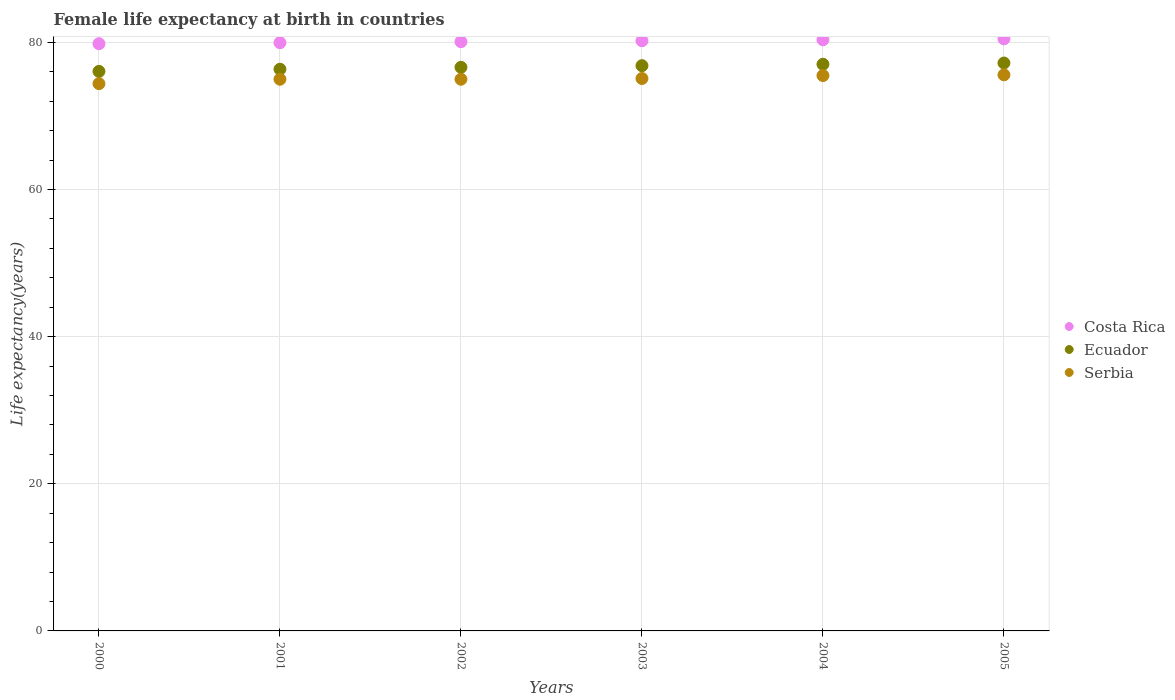How many different coloured dotlines are there?
Make the answer very short. 3. Is the number of dotlines equal to the number of legend labels?
Keep it short and to the point. Yes. What is the female life expectancy at birth in Ecuador in 2005?
Ensure brevity in your answer.  77.2. Across all years, what is the maximum female life expectancy at birth in Ecuador?
Make the answer very short. 77.2. Across all years, what is the minimum female life expectancy at birth in Costa Rica?
Provide a succinct answer. 79.83. In which year was the female life expectancy at birth in Costa Rica minimum?
Provide a short and direct response. 2000. What is the total female life expectancy at birth in Ecuador in the graph?
Keep it short and to the point. 460.13. What is the difference between the female life expectancy at birth in Ecuador in 2000 and that in 2005?
Make the answer very short. -1.14. What is the difference between the female life expectancy at birth in Ecuador in 2002 and the female life expectancy at birth in Costa Rica in 2005?
Your response must be concise. -3.87. What is the average female life expectancy at birth in Serbia per year?
Your response must be concise. 75.1. In the year 2001, what is the difference between the female life expectancy at birth in Serbia and female life expectancy at birth in Ecuador?
Offer a terse response. -1.36. What is the ratio of the female life expectancy at birth in Ecuador in 2001 to that in 2003?
Ensure brevity in your answer.  0.99. Is the female life expectancy at birth in Ecuador in 2001 less than that in 2005?
Provide a short and direct response. Yes. What is the difference between the highest and the second highest female life expectancy at birth in Ecuador?
Your response must be concise. 0.17. What is the difference between the highest and the lowest female life expectancy at birth in Ecuador?
Ensure brevity in your answer.  1.14. In how many years, is the female life expectancy at birth in Ecuador greater than the average female life expectancy at birth in Ecuador taken over all years?
Provide a succinct answer. 3. Is it the case that in every year, the sum of the female life expectancy at birth in Serbia and female life expectancy at birth in Ecuador  is greater than the female life expectancy at birth in Costa Rica?
Make the answer very short. Yes. Does the female life expectancy at birth in Ecuador monotonically increase over the years?
Provide a short and direct response. Yes. How many dotlines are there?
Provide a succinct answer. 3. How many years are there in the graph?
Give a very brief answer. 6. Are the values on the major ticks of Y-axis written in scientific E-notation?
Provide a short and direct response. No. Where does the legend appear in the graph?
Keep it short and to the point. Center right. What is the title of the graph?
Offer a very short reply. Female life expectancy at birth in countries. What is the label or title of the X-axis?
Keep it short and to the point. Years. What is the label or title of the Y-axis?
Your response must be concise. Life expectancy(years). What is the Life expectancy(years) of Costa Rica in 2000?
Your answer should be compact. 79.83. What is the Life expectancy(years) of Ecuador in 2000?
Give a very brief answer. 76.07. What is the Life expectancy(years) in Serbia in 2000?
Give a very brief answer. 74.4. What is the Life expectancy(years) of Costa Rica in 2001?
Provide a short and direct response. 79.97. What is the Life expectancy(years) of Ecuador in 2001?
Provide a short and direct response. 76.36. What is the Life expectancy(years) of Costa Rica in 2002?
Ensure brevity in your answer.  80.11. What is the Life expectancy(years) in Ecuador in 2002?
Give a very brief answer. 76.62. What is the Life expectancy(years) in Costa Rica in 2003?
Give a very brief answer. 80.24. What is the Life expectancy(years) in Ecuador in 2003?
Provide a short and direct response. 76.84. What is the Life expectancy(years) of Serbia in 2003?
Give a very brief answer. 75.1. What is the Life expectancy(years) in Costa Rica in 2004?
Give a very brief answer. 80.36. What is the Life expectancy(years) of Ecuador in 2004?
Provide a succinct answer. 77.04. What is the Life expectancy(years) of Serbia in 2004?
Keep it short and to the point. 75.5. What is the Life expectancy(years) in Costa Rica in 2005?
Make the answer very short. 80.5. What is the Life expectancy(years) in Ecuador in 2005?
Ensure brevity in your answer.  77.2. What is the Life expectancy(years) of Serbia in 2005?
Your response must be concise. 75.6. Across all years, what is the maximum Life expectancy(years) in Costa Rica?
Provide a succinct answer. 80.5. Across all years, what is the maximum Life expectancy(years) in Ecuador?
Keep it short and to the point. 77.2. Across all years, what is the maximum Life expectancy(years) in Serbia?
Provide a short and direct response. 75.6. Across all years, what is the minimum Life expectancy(years) in Costa Rica?
Provide a short and direct response. 79.83. Across all years, what is the minimum Life expectancy(years) in Ecuador?
Offer a terse response. 76.07. Across all years, what is the minimum Life expectancy(years) in Serbia?
Offer a very short reply. 74.4. What is the total Life expectancy(years) of Costa Rica in the graph?
Give a very brief answer. 481. What is the total Life expectancy(years) in Ecuador in the graph?
Make the answer very short. 460.13. What is the total Life expectancy(years) in Serbia in the graph?
Offer a terse response. 450.6. What is the difference between the Life expectancy(years) of Costa Rica in 2000 and that in 2001?
Your answer should be compact. -0.14. What is the difference between the Life expectancy(years) in Ecuador in 2000 and that in 2001?
Offer a very short reply. -0.3. What is the difference between the Life expectancy(years) in Serbia in 2000 and that in 2001?
Provide a succinct answer. -0.6. What is the difference between the Life expectancy(years) of Costa Rica in 2000 and that in 2002?
Give a very brief answer. -0.28. What is the difference between the Life expectancy(years) in Ecuador in 2000 and that in 2002?
Ensure brevity in your answer.  -0.56. What is the difference between the Life expectancy(years) of Costa Rica in 2000 and that in 2003?
Make the answer very short. -0.41. What is the difference between the Life expectancy(years) in Ecuador in 2000 and that in 2003?
Keep it short and to the point. -0.78. What is the difference between the Life expectancy(years) in Serbia in 2000 and that in 2003?
Provide a short and direct response. -0.7. What is the difference between the Life expectancy(years) of Costa Rica in 2000 and that in 2004?
Give a very brief answer. -0.54. What is the difference between the Life expectancy(years) in Ecuador in 2000 and that in 2004?
Ensure brevity in your answer.  -0.97. What is the difference between the Life expectancy(years) in Costa Rica in 2000 and that in 2005?
Provide a succinct answer. -0.67. What is the difference between the Life expectancy(years) of Ecuador in 2000 and that in 2005?
Offer a very short reply. -1.14. What is the difference between the Life expectancy(years) in Serbia in 2000 and that in 2005?
Your answer should be compact. -1.2. What is the difference between the Life expectancy(years) of Costa Rica in 2001 and that in 2002?
Make the answer very short. -0.14. What is the difference between the Life expectancy(years) of Ecuador in 2001 and that in 2002?
Give a very brief answer. -0.26. What is the difference between the Life expectancy(years) of Costa Rica in 2001 and that in 2003?
Your response must be concise. -0.27. What is the difference between the Life expectancy(years) in Ecuador in 2001 and that in 2003?
Give a very brief answer. -0.48. What is the difference between the Life expectancy(years) of Costa Rica in 2001 and that in 2004?
Make the answer very short. -0.4. What is the difference between the Life expectancy(years) in Ecuador in 2001 and that in 2004?
Give a very brief answer. -0.68. What is the difference between the Life expectancy(years) of Serbia in 2001 and that in 2004?
Your answer should be compact. -0.5. What is the difference between the Life expectancy(years) in Costa Rica in 2001 and that in 2005?
Keep it short and to the point. -0.53. What is the difference between the Life expectancy(years) of Ecuador in 2001 and that in 2005?
Keep it short and to the point. -0.84. What is the difference between the Life expectancy(years) in Serbia in 2001 and that in 2005?
Provide a short and direct response. -0.6. What is the difference between the Life expectancy(years) in Costa Rica in 2002 and that in 2003?
Make the answer very short. -0.13. What is the difference between the Life expectancy(years) in Ecuador in 2002 and that in 2003?
Your answer should be very brief. -0.22. What is the difference between the Life expectancy(years) of Costa Rica in 2002 and that in 2004?
Ensure brevity in your answer.  -0.26. What is the difference between the Life expectancy(years) in Ecuador in 2002 and that in 2004?
Your answer should be compact. -0.42. What is the difference between the Life expectancy(years) in Costa Rica in 2002 and that in 2005?
Your response must be concise. -0.39. What is the difference between the Life expectancy(years) of Ecuador in 2002 and that in 2005?
Provide a short and direct response. -0.58. What is the difference between the Life expectancy(years) of Serbia in 2002 and that in 2005?
Offer a terse response. -0.6. What is the difference between the Life expectancy(years) in Costa Rica in 2003 and that in 2004?
Your answer should be very brief. -0.13. What is the difference between the Life expectancy(years) in Ecuador in 2003 and that in 2004?
Offer a terse response. -0.19. What is the difference between the Life expectancy(years) in Costa Rica in 2003 and that in 2005?
Give a very brief answer. -0.26. What is the difference between the Life expectancy(years) in Ecuador in 2003 and that in 2005?
Your answer should be very brief. -0.36. What is the difference between the Life expectancy(years) of Costa Rica in 2004 and that in 2005?
Make the answer very short. -0.13. What is the difference between the Life expectancy(years) in Ecuador in 2004 and that in 2005?
Ensure brevity in your answer.  -0.17. What is the difference between the Life expectancy(years) of Costa Rica in 2000 and the Life expectancy(years) of Ecuador in 2001?
Make the answer very short. 3.47. What is the difference between the Life expectancy(years) in Costa Rica in 2000 and the Life expectancy(years) in Serbia in 2001?
Ensure brevity in your answer.  4.83. What is the difference between the Life expectancy(years) of Ecuador in 2000 and the Life expectancy(years) of Serbia in 2001?
Ensure brevity in your answer.  1.07. What is the difference between the Life expectancy(years) of Costa Rica in 2000 and the Life expectancy(years) of Ecuador in 2002?
Offer a terse response. 3.21. What is the difference between the Life expectancy(years) of Costa Rica in 2000 and the Life expectancy(years) of Serbia in 2002?
Keep it short and to the point. 4.83. What is the difference between the Life expectancy(years) in Ecuador in 2000 and the Life expectancy(years) in Serbia in 2002?
Keep it short and to the point. 1.07. What is the difference between the Life expectancy(years) of Costa Rica in 2000 and the Life expectancy(years) of Ecuador in 2003?
Provide a short and direct response. 2.99. What is the difference between the Life expectancy(years) of Costa Rica in 2000 and the Life expectancy(years) of Serbia in 2003?
Provide a succinct answer. 4.73. What is the difference between the Life expectancy(years) of Ecuador in 2000 and the Life expectancy(years) of Serbia in 2003?
Offer a terse response. 0.97. What is the difference between the Life expectancy(years) of Costa Rica in 2000 and the Life expectancy(years) of Ecuador in 2004?
Give a very brief answer. 2.79. What is the difference between the Life expectancy(years) in Costa Rica in 2000 and the Life expectancy(years) in Serbia in 2004?
Your answer should be compact. 4.33. What is the difference between the Life expectancy(years) of Ecuador in 2000 and the Life expectancy(years) of Serbia in 2004?
Ensure brevity in your answer.  0.57. What is the difference between the Life expectancy(years) of Costa Rica in 2000 and the Life expectancy(years) of Ecuador in 2005?
Your answer should be very brief. 2.62. What is the difference between the Life expectancy(years) of Costa Rica in 2000 and the Life expectancy(years) of Serbia in 2005?
Provide a short and direct response. 4.23. What is the difference between the Life expectancy(years) in Ecuador in 2000 and the Life expectancy(years) in Serbia in 2005?
Your answer should be compact. 0.47. What is the difference between the Life expectancy(years) in Costa Rica in 2001 and the Life expectancy(years) in Ecuador in 2002?
Your answer should be compact. 3.35. What is the difference between the Life expectancy(years) in Costa Rica in 2001 and the Life expectancy(years) in Serbia in 2002?
Keep it short and to the point. 4.97. What is the difference between the Life expectancy(years) of Ecuador in 2001 and the Life expectancy(years) of Serbia in 2002?
Make the answer very short. 1.36. What is the difference between the Life expectancy(years) in Costa Rica in 2001 and the Life expectancy(years) in Ecuador in 2003?
Keep it short and to the point. 3.13. What is the difference between the Life expectancy(years) in Costa Rica in 2001 and the Life expectancy(years) in Serbia in 2003?
Keep it short and to the point. 4.87. What is the difference between the Life expectancy(years) of Ecuador in 2001 and the Life expectancy(years) of Serbia in 2003?
Your answer should be compact. 1.26. What is the difference between the Life expectancy(years) in Costa Rica in 2001 and the Life expectancy(years) in Ecuador in 2004?
Offer a very short reply. 2.93. What is the difference between the Life expectancy(years) of Costa Rica in 2001 and the Life expectancy(years) of Serbia in 2004?
Your answer should be very brief. 4.47. What is the difference between the Life expectancy(years) of Ecuador in 2001 and the Life expectancy(years) of Serbia in 2004?
Provide a succinct answer. 0.86. What is the difference between the Life expectancy(years) in Costa Rica in 2001 and the Life expectancy(years) in Ecuador in 2005?
Keep it short and to the point. 2.77. What is the difference between the Life expectancy(years) in Costa Rica in 2001 and the Life expectancy(years) in Serbia in 2005?
Your answer should be very brief. 4.37. What is the difference between the Life expectancy(years) in Ecuador in 2001 and the Life expectancy(years) in Serbia in 2005?
Your answer should be compact. 0.76. What is the difference between the Life expectancy(years) in Costa Rica in 2002 and the Life expectancy(years) in Ecuador in 2003?
Ensure brevity in your answer.  3.26. What is the difference between the Life expectancy(years) of Costa Rica in 2002 and the Life expectancy(years) of Serbia in 2003?
Offer a terse response. 5. What is the difference between the Life expectancy(years) in Ecuador in 2002 and the Life expectancy(years) in Serbia in 2003?
Offer a terse response. 1.52. What is the difference between the Life expectancy(years) of Costa Rica in 2002 and the Life expectancy(years) of Ecuador in 2004?
Offer a very short reply. 3.07. What is the difference between the Life expectancy(years) in Costa Rica in 2002 and the Life expectancy(years) in Serbia in 2004?
Make the answer very short. 4.61. What is the difference between the Life expectancy(years) in Ecuador in 2002 and the Life expectancy(years) in Serbia in 2004?
Provide a short and direct response. 1.12. What is the difference between the Life expectancy(years) in Costa Rica in 2002 and the Life expectancy(years) in Ecuador in 2005?
Keep it short and to the point. 2.9. What is the difference between the Life expectancy(years) of Costa Rica in 2002 and the Life expectancy(years) of Serbia in 2005?
Provide a short and direct response. 4.5. What is the difference between the Life expectancy(years) of Ecuador in 2002 and the Life expectancy(years) of Serbia in 2005?
Give a very brief answer. 1.02. What is the difference between the Life expectancy(years) in Costa Rica in 2003 and the Life expectancy(years) in Ecuador in 2004?
Provide a succinct answer. 3.2. What is the difference between the Life expectancy(years) in Costa Rica in 2003 and the Life expectancy(years) in Serbia in 2004?
Offer a very short reply. 4.74. What is the difference between the Life expectancy(years) of Ecuador in 2003 and the Life expectancy(years) of Serbia in 2004?
Give a very brief answer. 1.34. What is the difference between the Life expectancy(years) of Costa Rica in 2003 and the Life expectancy(years) of Ecuador in 2005?
Keep it short and to the point. 3.03. What is the difference between the Life expectancy(years) of Costa Rica in 2003 and the Life expectancy(years) of Serbia in 2005?
Give a very brief answer. 4.64. What is the difference between the Life expectancy(years) in Ecuador in 2003 and the Life expectancy(years) in Serbia in 2005?
Provide a short and direct response. 1.24. What is the difference between the Life expectancy(years) in Costa Rica in 2004 and the Life expectancy(years) in Ecuador in 2005?
Keep it short and to the point. 3.16. What is the difference between the Life expectancy(years) in Costa Rica in 2004 and the Life expectancy(years) in Serbia in 2005?
Provide a short and direct response. 4.76. What is the difference between the Life expectancy(years) of Ecuador in 2004 and the Life expectancy(years) of Serbia in 2005?
Offer a very short reply. 1.44. What is the average Life expectancy(years) in Costa Rica per year?
Your answer should be very brief. 80.17. What is the average Life expectancy(years) of Ecuador per year?
Ensure brevity in your answer.  76.69. What is the average Life expectancy(years) of Serbia per year?
Offer a very short reply. 75.1. In the year 2000, what is the difference between the Life expectancy(years) in Costa Rica and Life expectancy(years) in Ecuador?
Your answer should be very brief. 3.76. In the year 2000, what is the difference between the Life expectancy(years) of Costa Rica and Life expectancy(years) of Serbia?
Give a very brief answer. 5.43. In the year 2000, what is the difference between the Life expectancy(years) in Ecuador and Life expectancy(years) in Serbia?
Keep it short and to the point. 1.67. In the year 2001, what is the difference between the Life expectancy(years) of Costa Rica and Life expectancy(years) of Ecuador?
Ensure brevity in your answer.  3.61. In the year 2001, what is the difference between the Life expectancy(years) in Costa Rica and Life expectancy(years) in Serbia?
Ensure brevity in your answer.  4.97. In the year 2001, what is the difference between the Life expectancy(years) in Ecuador and Life expectancy(years) in Serbia?
Keep it short and to the point. 1.36. In the year 2002, what is the difference between the Life expectancy(years) of Costa Rica and Life expectancy(years) of Ecuador?
Make the answer very short. 3.48. In the year 2002, what is the difference between the Life expectancy(years) of Costa Rica and Life expectancy(years) of Serbia?
Your response must be concise. 5.11. In the year 2002, what is the difference between the Life expectancy(years) in Ecuador and Life expectancy(years) in Serbia?
Give a very brief answer. 1.62. In the year 2003, what is the difference between the Life expectancy(years) in Costa Rica and Life expectancy(years) in Ecuador?
Your answer should be compact. 3.39. In the year 2003, what is the difference between the Life expectancy(years) in Costa Rica and Life expectancy(years) in Serbia?
Give a very brief answer. 5.14. In the year 2003, what is the difference between the Life expectancy(years) in Ecuador and Life expectancy(years) in Serbia?
Give a very brief answer. 1.74. In the year 2004, what is the difference between the Life expectancy(years) of Costa Rica and Life expectancy(years) of Ecuador?
Your response must be concise. 3.33. In the year 2004, what is the difference between the Life expectancy(years) in Costa Rica and Life expectancy(years) in Serbia?
Give a very brief answer. 4.87. In the year 2004, what is the difference between the Life expectancy(years) in Ecuador and Life expectancy(years) in Serbia?
Make the answer very short. 1.54. In the year 2005, what is the difference between the Life expectancy(years) of Costa Rica and Life expectancy(years) of Ecuador?
Your response must be concise. 3.29. In the year 2005, what is the difference between the Life expectancy(years) in Costa Rica and Life expectancy(years) in Serbia?
Offer a terse response. 4.89. In the year 2005, what is the difference between the Life expectancy(years) in Ecuador and Life expectancy(years) in Serbia?
Your answer should be very brief. 1.6. What is the ratio of the Life expectancy(years) of Costa Rica in 2000 to that in 2001?
Your answer should be compact. 1. What is the ratio of the Life expectancy(years) of Ecuador in 2000 to that in 2001?
Your response must be concise. 1. What is the ratio of the Life expectancy(years) of Costa Rica in 2000 to that in 2002?
Give a very brief answer. 1. What is the ratio of the Life expectancy(years) in Costa Rica in 2000 to that in 2003?
Make the answer very short. 0.99. What is the ratio of the Life expectancy(years) of Serbia in 2000 to that in 2003?
Make the answer very short. 0.99. What is the ratio of the Life expectancy(years) in Ecuador in 2000 to that in 2004?
Ensure brevity in your answer.  0.99. What is the ratio of the Life expectancy(years) of Serbia in 2000 to that in 2004?
Provide a short and direct response. 0.99. What is the ratio of the Life expectancy(years) of Ecuador in 2000 to that in 2005?
Ensure brevity in your answer.  0.99. What is the ratio of the Life expectancy(years) of Serbia in 2000 to that in 2005?
Make the answer very short. 0.98. What is the ratio of the Life expectancy(years) in Costa Rica in 2001 to that in 2002?
Your answer should be compact. 1. What is the ratio of the Life expectancy(years) in Costa Rica in 2001 to that in 2003?
Offer a terse response. 1. What is the ratio of the Life expectancy(years) in Costa Rica in 2001 to that in 2005?
Your response must be concise. 0.99. What is the ratio of the Life expectancy(years) of Ecuador in 2001 to that in 2005?
Your answer should be very brief. 0.99. What is the ratio of the Life expectancy(years) in Ecuador in 2002 to that in 2003?
Offer a terse response. 1. What is the ratio of the Life expectancy(years) of Serbia in 2002 to that in 2003?
Your answer should be very brief. 1. What is the ratio of the Life expectancy(years) in Costa Rica in 2002 to that in 2005?
Give a very brief answer. 1. What is the ratio of the Life expectancy(years) in Ecuador in 2002 to that in 2005?
Provide a short and direct response. 0.99. What is the ratio of the Life expectancy(years) of Costa Rica in 2003 to that in 2004?
Your response must be concise. 1. What is the ratio of the Life expectancy(years) in Serbia in 2003 to that in 2005?
Keep it short and to the point. 0.99. What is the ratio of the Life expectancy(years) of Costa Rica in 2004 to that in 2005?
Your response must be concise. 1. What is the ratio of the Life expectancy(years) in Ecuador in 2004 to that in 2005?
Your answer should be very brief. 1. What is the ratio of the Life expectancy(years) in Serbia in 2004 to that in 2005?
Offer a terse response. 1. What is the difference between the highest and the second highest Life expectancy(years) in Costa Rica?
Offer a terse response. 0.13. What is the difference between the highest and the second highest Life expectancy(years) of Ecuador?
Your answer should be compact. 0.17. What is the difference between the highest and the lowest Life expectancy(years) of Costa Rica?
Make the answer very short. 0.67. What is the difference between the highest and the lowest Life expectancy(years) of Ecuador?
Make the answer very short. 1.14. 